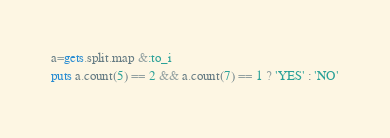<code> <loc_0><loc_0><loc_500><loc_500><_Ruby_>a=gets.split.map &:to_i
puts a.count(5) == 2 && a.count(7) == 1 ? 'YES' : 'NO'</code> 